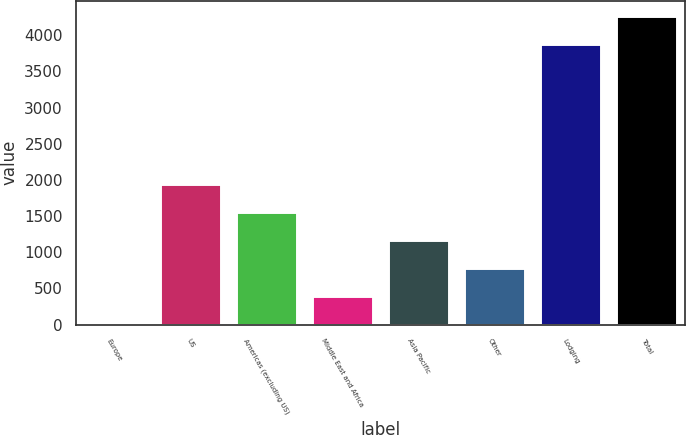Convert chart. <chart><loc_0><loc_0><loc_500><loc_500><bar_chart><fcel>Europe<fcel>US<fcel>Americas (excluding US)<fcel>Middle East and Africa<fcel>Asia Pacific<fcel>Other<fcel>Lodging<fcel>Total<nl><fcel>1<fcel>1938<fcel>1550.6<fcel>388.4<fcel>1163.2<fcel>775.8<fcel>3875<fcel>4262.4<nl></chart> 